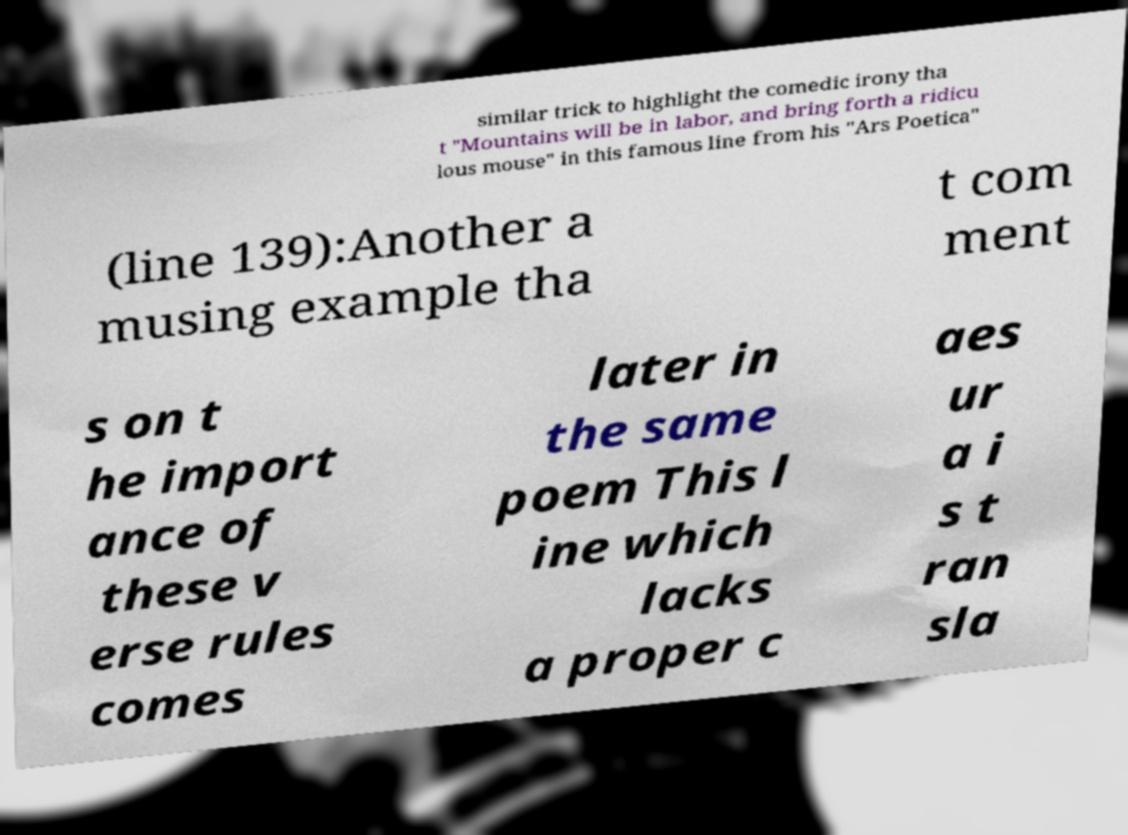There's text embedded in this image that I need extracted. Can you transcribe it verbatim? similar trick to highlight the comedic irony tha t "Mountains will be in labor, and bring forth a ridicu lous mouse" in this famous line from his "Ars Poetica" (line 139):Another a musing example tha t com ment s on t he import ance of these v erse rules comes later in the same poem This l ine which lacks a proper c aes ur a i s t ran sla 